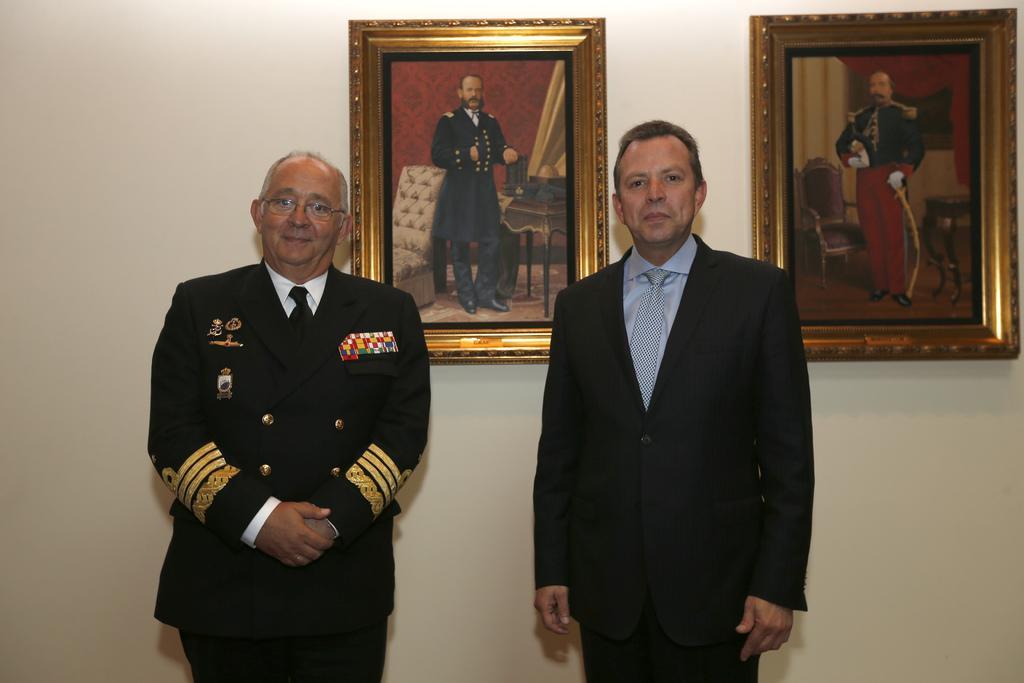Describe this image in one or two sentences. In this image there is a person wearing a suit and tie. He is standing beside a person wearing a uniform. Behind them there are two picture frames attached to the wall. Left side person is wearing spectacles and tie. 